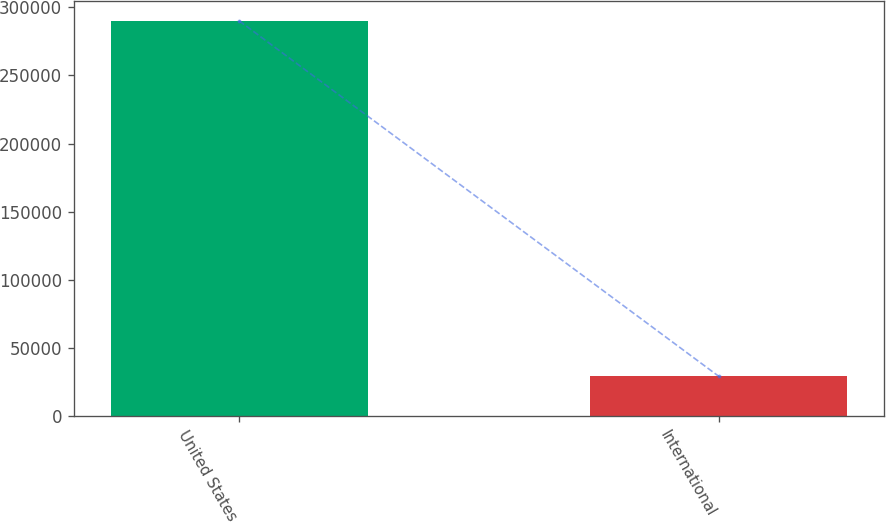Convert chart. <chart><loc_0><loc_0><loc_500><loc_500><bar_chart><fcel>United States<fcel>International<nl><fcel>289875<fcel>29529<nl></chart> 